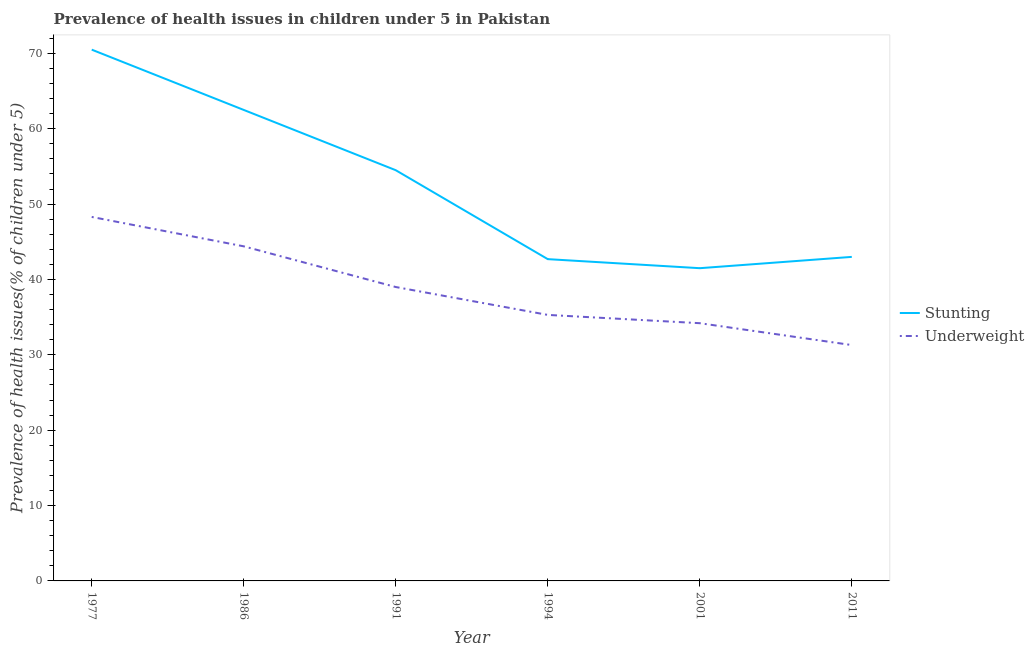What is the percentage of stunted children in 2001?
Provide a succinct answer. 41.5. Across all years, what is the maximum percentage of underweight children?
Keep it short and to the point. 48.3. Across all years, what is the minimum percentage of stunted children?
Ensure brevity in your answer.  41.5. In which year was the percentage of stunted children maximum?
Offer a terse response. 1977. In which year was the percentage of underweight children minimum?
Your response must be concise. 2011. What is the total percentage of underweight children in the graph?
Give a very brief answer. 232.5. What is the difference between the percentage of underweight children in 1977 and that in 1994?
Make the answer very short. 13. What is the difference between the percentage of underweight children in 1977 and the percentage of stunted children in 1991?
Your answer should be very brief. -6.2. What is the average percentage of stunted children per year?
Ensure brevity in your answer.  52.45. In the year 2011, what is the difference between the percentage of underweight children and percentage of stunted children?
Your answer should be very brief. -11.7. In how many years, is the percentage of underweight children greater than 4 %?
Make the answer very short. 6. What is the ratio of the percentage of stunted children in 1991 to that in 1994?
Your response must be concise. 1.28. Is the percentage of underweight children in 1991 less than that in 2011?
Offer a very short reply. No. Is the difference between the percentage of underweight children in 1986 and 1994 greater than the difference between the percentage of stunted children in 1986 and 1994?
Your answer should be very brief. No. What is the difference between the highest and the second highest percentage of underweight children?
Your response must be concise. 3.9. What is the difference between the highest and the lowest percentage of underweight children?
Your response must be concise. 17. In how many years, is the percentage of stunted children greater than the average percentage of stunted children taken over all years?
Keep it short and to the point. 3. Is the percentage of underweight children strictly less than the percentage of stunted children over the years?
Your response must be concise. Yes. How many lines are there?
Provide a short and direct response. 2. What is the difference between two consecutive major ticks on the Y-axis?
Provide a succinct answer. 10. Does the graph contain any zero values?
Give a very brief answer. No. Where does the legend appear in the graph?
Your answer should be compact. Center right. How many legend labels are there?
Your answer should be compact. 2. How are the legend labels stacked?
Keep it short and to the point. Vertical. What is the title of the graph?
Offer a terse response. Prevalence of health issues in children under 5 in Pakistan. What is the label or title of the Y-axis?
Give a very brief answer. Prevalence of health issues(% of children under 5). What is the Prevalence of health issues(% of children under 5) in Stunting in 1977?
Your answer should be compact. 70.5. What is the Prevalence of health issues(% of children under 5) of Underweight in 1977?
Provide a succinct answer. 48.3. What is the Prevalence of health issues(% of children under 5) in Stunting in 1986?
Offer a terse response. 62.5. What is the Prevalence of health issues(% of children under 5) in Underweight in 1986?
Make the answer very short. 44.4. What is the Prevalence of health issues(% of children under 5) in Stunting in 1991?
Keep it short and to the point. 54.5. What is the Prevalence of health issues(% of children under 5) in Underweight in 1991?
Your response must be concise. 39. What is the Prevalence of health issues(% of children under 5) of Stunting in 1994?
Your response must be concise. 42.7. What is the Prevalence of health issues(% of children under 5) of Underweight in 1994?
Keep it short and to the point. 35.3. What is the Prevalence of health issues(% of children under 5) of Stunting in 2001?
Your answer should be compact. 41.5. What is the Prevalence of health issues(% of children under 5) of Underweight in 2001?
Offer a very short reply. 34.2. What is the Prevalence of health issues(% of children under 5) in Stunting in 2011?
Your answer should be compact. 43. What is the Prevalence of health issues(% of children under 5) of Underweight in 2011?
Ensure brevity in your answer.  31.3. Across all years, what is the maximum Prevalence of health issues(% of children under 5) of Stunting?
Ensure brevity in your answer.  70.5. Across all years, what is the maximum Prevalence of health issues(% of children under 5) in Underweight?
Offer a very short reply. 48.3. Across all years, what is the minimum Prevalence of health issues(% of children under 5) in Stunting?
Give a very brief answer. 41.5. Across all years, what is the minimum Prevalence of health issues(% of children under 5) of Underweight?
Provide a short and direct response. 31.3. What is the total Prevalence of health issues(% of children under 5) in Stunting in the graph?
Your answer should be very brief. 314.7. What is the total Prevalence of health issues(% of children under 5) of Underweight in the graph?
Offer a very short reply. 232.5. What is the difference between the Prevalence of health issues(% of children under 5) in Underweight in 1977 and that in 1986?
Your answer should be compact. 3.9. What is the difference between the Prevalence of health issues(% of children under 5) in Underweight in 1977 and that in 1991?
Keep it short and to the point. 9.3. What is the difference between the Prevalence of health issues(% of children under 5) of Stunting in 1977 and that in 1994?
Provide a short and direct response. 27.8. What is the difference between the Prevalence of health issues(% of children under 5) in Underweight in 1977 and that in 2001?
Your answer should be compact. 14.1. What is the difference between the Prevalence of health issues(% of children under 5) of Stunting in 1977 and that in 2011?
Ensure brevity in your answer.  27.5. What is the difference between the Prevalence of health issues(% of children under 5) of Stunting in 1986 and that in 1991?
Provide a short and direct response. 8. What is the difference between the Prevalence of health issues(% of children under 5) in Underweight in 1986 and that in 1991?
Offer a very short reply. 5.4. What is the difference between the Prevalence of health issues(% of children under 5) of Stunting in 1986 and that in 1994?
Provide a succinct answer. 19.8. What is the difference between the Prevalence of health issues(% of children under 5) of Underweight in 1986 and that in 2001?
Give a very brief answer. 10.2. What is the difference between the Prevalence of health issues(% of children under 5) of Underweight in 1986 and that in 2011?
Make the answer very short. 13.1. What is the difference between the Prevalence of health issues(% of children under 5) of Underweight in 1991 and that in 2011?
Provide a short and direct response. 7.7. What is the difference between the Prevalence of health issues(% of children under 5) in Underweight in 1994 and that in 2001?
Provide a succinct answer. 1.1. What is the difference between the Prevalence of health issues(% of children under 5) in Stunting in 1994 and that in 2011?
Offer a very short reply. -0.3. What is the difference between the Prevalence of health issues(% of children under 5) in Stunting in 2001 and that in 2011?
Your answer should be very brief. -1.5. What is the difference between the Prevalence of health issues(% of children under 5) of Underweight in 2001 and that in 2011?
Keep it short and to the point. 2.9. What is the difference between the Prevalence of health issues(% of children under 5) in Stunting in 1977 and the Prevalence of health issues(% of children under 5) in Underweight in 1986?
Give a very brief answer. 26.1. What is the difference between the Prevalence of health issues(% of children under 5) of Stunting in 1977 and the Prevalence of health issues(% of children under 5) of Underweight in 1991?
Provide a short and direct response. 31.5. What is the difference between the Prevalence of health issues(% of children under 5) of Stunting in 1977 and the Prevalence of health issues(% of children under 5) of Underweight in 1994?
Make the answer very short. 35.2. What is the difference between the Prevalence of health issues(% of children under 5) of Stunting in 1977 and the Prevalence of health issues(% of children under 5) of Underweight in 2001?
Offer a very short reply. 36.3. What is the difference between the Prevalence of health issues(% of children under 5) of Stunting in 1977 and the Prevalence of health issues(% of children under 5) of Underweight in 2011?
Make the answer very short. 39.2. What is the difference between the Prevalence of health issues(% of children under 5) of Stunting in 1986 and the Prevalence of health issues(% of children under 5) of Underweight in 1994?
Offer a terse response. 27.2. What is the difference between the Prevalence of health issues(% of children under 5) of Stunting in 1986 and the Prevalence of health issues(% of children under 5) of Underweight in 2001?
Offer a very short reply. 28.3. What is the difference between the Prevalence of health issues(% of children under 5) in Stunting in 1986 and the Prevalence of health issues(% of children under 5) in Underweight in 2011?
Offer a very short reply. 31.2. What is the difference between the Prevalence of health issues(% of children under 5) in Stunting in 1991 and the Prevalence of health issues(% of children under 5) in Underweight in 1994?
Your answer should be very brief. 19.2. What is the difference between the Prevalence of health issues(% of children under 5) in Stunting in 1991 and the Prevalence of health issues(% of children under 5) in Underweight in 2001?
Your answer should be compact. 20.3. What is the difference between the Prevalence of health issues(% of children under 5) of Stunting in 1991 and the Prevalence of health issues(% of children under 5) of Underweight in 2011?
Ensure brevity in your answer.  23.2. What is the difference between the Prevalence of health issues(% of children under 5) in Stunting in 1994 and the Prevalence of health issues(% of children under 5) in Underweight in 2001?
Ensure brevity in your answer.  8.5. What is the average Prevalence of health issues(% of children under 5) in Stunting per year?
Your answer should be compact. 52.45. What is the average Prevalence of health issues(% of children under 5) in Underweight per year?
Provide a succinct answer. 38.75. In the year 1977, what is the difference between the Prevalence of health issues(% of children under 5) in Stunting and Prevalence of health issues(% of children under 5) in Underweight?
Provide a succinct answer. 22.2. In the year 1986, what is the difference between the Prevalence of health issues(% of children under 5) in Stunting and Prevalence of health issues(% of children under 5) in Underweight?
Make the answer very short. 18.1. In the year 1991, what is the difference between the Prevalence of health issues(% of children under 5) in Stunting and Prevalence of health issues(% of children under 5) in Underweight?
Your answer should be compact. 15.5. In the year 2001, what is the difference between the Prevalence of health issues(% of children under 5) of Stunting and Prevalence of health issues(% of children under 5) of Underweight?
Provide a short and direct response. 7.3. In the year 2011, what is the difference between the Prevalence of health issues(% of children under 5) of Stunting and Prevalence of health issues(% of children under 5) of Underweight?
Offer a terse response. 11.7. What is the ratio of the Prevalence of health issues(% of children under 5) of Stunting in 1977 to that in 1986?
Keep it short and to the point. 1.13. What is the ratio of the Prevalence of health issues(% of children under 5) in Underweight in 1977 to that in 1986?
Your answer should be compact. 1.09. What is the ratio of the Prevalence of health issues(% of children under 5) of Stunting in 1977 to that in 1991?
Provide a short and direct response. 1.29. What is the ratio of the Prevalence of health issues(% of children under 5) in Underweight in 1977 to that in 1991?
Provide a succinct answer. 1.24. What is the ratio of the Prevalence of health issues(% of children under 5) of Stunting in 1977 to that in 1994?
Your response must be concise. 1.65. What is the ratio of the Prevalence of health issues(% of children under 5) in Underweight in 1977 to that in 1994?
Your answer should be very brief. 1.37. What is the ratio of the Prevalence of health issues(% of children under 5) of Stunting in 1977 to that in 2001?
Provide a short and direct response. 1.7. What is the ratio of the Prevalence of health issues(% of children under 5) in Underweight in 1977 to that in 2001?
Ensure brevity in your answer.  1.41. What is the ratio of the Prevalence of health issues(% of children under 5) in Stunting in 1977 to that in 2011?
Your response must be concise. 1.64. What is the ratio of the Prevalence of health issues(% of children under 5) of Underweight in 1977 to that in 2011?
Your answer should be very brief. 1.54. What is the ratio of the Prevalence of health issues(% of children under 5) in Stunting in 1986 to that in 1991?
Give a very brief answer. 1.15. What is the ratio of the Prevalence of health issues(% of children under 5) of Underweight in 1986 to that in 1991?
Offer a very short reply. 1.14. What is the ratio of the Prevalence of health issues(% of children under 5) in Stunting in 1986 to that in 1994?
Ensure brevity in your answer.  1.46. What is the ratio of the Prevalence of health issues(% of children under 5) in Underweight in 1986 to that in 1994?
Ensure brevity in your answer.  1.26. What is the ratio of the Prevalence of health issues(% of children under 5) in Stunting in 1986 to that in 2001?
Give a very brief answer. 1.51. What is the ratio of the Prevalence of health issues(% of children under 5) in Underweight in 1986 to that in 2001?
Keep it short and to the point. 1.3. What is the ratio of the Prevalence of health issues(% of children under 5) of Stunting in 1986 to that in 2011?
Give a very brief answer. 1.45. What is the ratio of the Prevalence of health issues(% of children under 5) of Underweight in 1986 to that in 2011?
Your response must be concise. 1.42. What is the ratio of the Prevalence of health issues(% of children under 5) of Stunting in 1991 to that in 1994?
Your answer should be very brief. 1.28. What is the ratio of the Prevalence of health issues(% of children under 5) in Underweight in 1991 to that in 1994?
Offer a very short reply. 1.1. What is the ratio of the Prevalence of health issues(% of children under 5) in Stunting in 1991 to that in 2001?
Give a very brief answer. 1.31. What is the ratio of the Prevalence of health issues(% of children under 5) of Underweight in 1991 to that in 2001?
Your answer should be very brief. 1.14. What is the ratio of the Prevalence of health issues(% of children under 5) of Stunting in 1991 to that in 2011?
Ensure brevity in your answer.  1.27. What is the ratio of the Prevalence of health issues(% of children under 5) in Underweight in 1991 to that in 2011?
Make the answer very short. 1.25. What is the ratio of the Prevalence of health issues(% of children under 5) of Stunting in 1994 to that in 2001?
Keep it short and to the point. 1.03. What is the ratio of the Prevalence of health issues(% of children under 5) of Underweight in 1994 to that in 2001?
Your answer should be compact. 1.03. What is the ratio of the Prevalence of health issues(% of children under 5) of Underweight in 1994 to that in 2011?
Provide a succinct answer. 1.13. What is the ratio of the Prevalence of health issues(% of children under 5) in Stunting in 2001 to that in 2011?
Ensure brevity in your answer.  0.97. What is the ratio of the Prevalence of health issues(% of children under 5) of Underweight in 2001 to that in 2011?
Provide a short and direct response. 1.09. What is the difference between the highest and the second highest Prevalence of health issues(% of children under 5) in Stunting?
Keep it short and to the point. 8. What is the difference between the highest and the second highest Prevalence of health issues(% of children under 5) of Underweight?
Ensure brevity in your answer.  3.9. What is the difference between the highest and the lowest Prevalence of health issues(% of children under 5) of Stunting?
Keep it short and to the point. 29. 